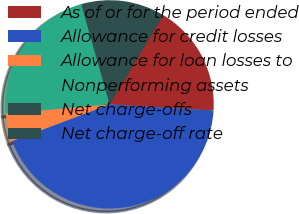<chart> <loc_0><loc_0><loc_500><loc_500><pie_chart><fcel>As of or for the period ended<fcel>Allowance for credit losses<fcel>Allowance for loan losses to<fcel>Nonperforming assets<fcel>Net charge-offs<fcel>Net charge-off rate<nl><fcel>17.33%<fcel>43.32%<fcel>4.33%<fcel>22.02%<fcel>13.0%<fcel>0.0%<nl></chart> 